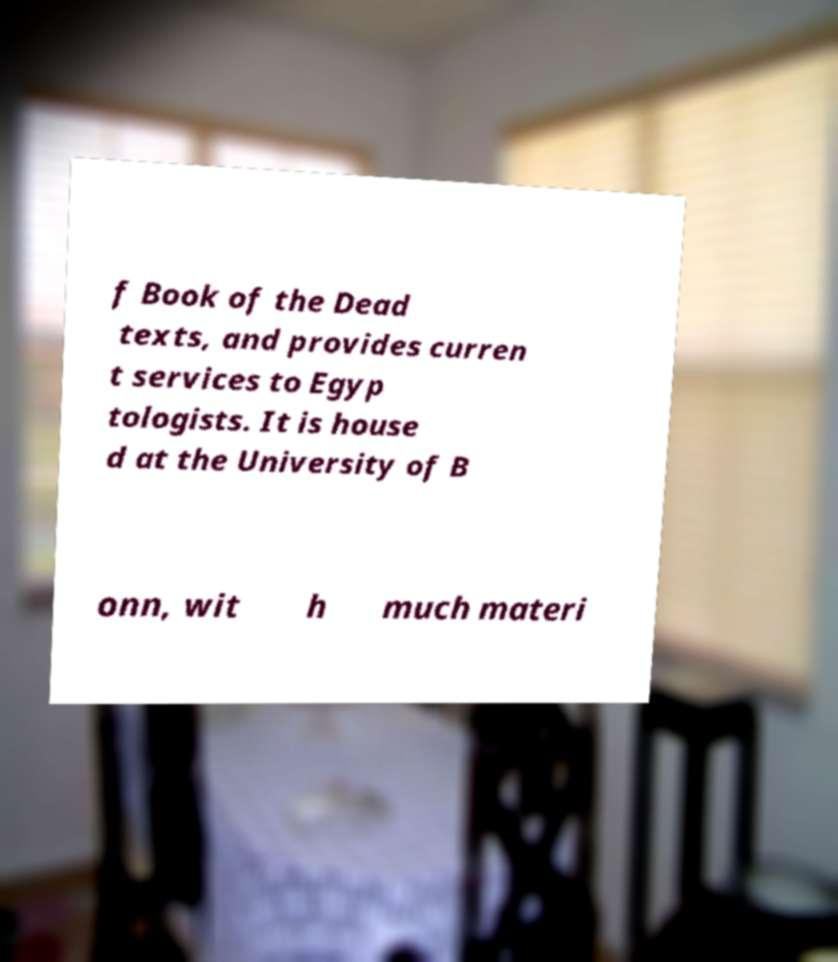Can you accurately transcribe the text from the provided image for me? f Book of the Dead texts, and provides curren t services to Egyp tologists. It is house d at the University of B onn, wit h much materi 